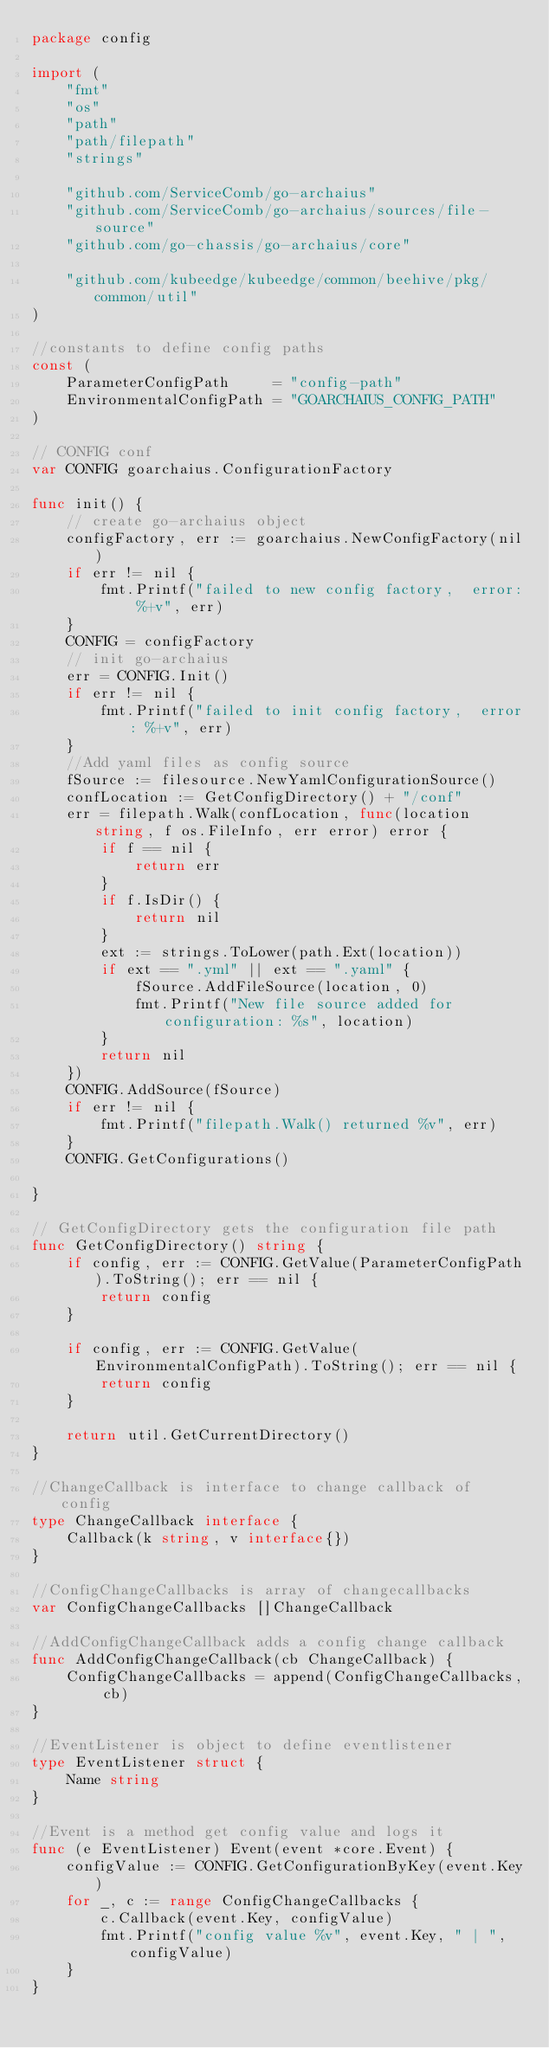Convert code to text. <code><loc_0><loc_0><loc_500><loc_500><_Go_>package config

import (
	"fmt"
	"os"
	"path"
	"path/filepath"
	"strings"

	"github.com/ServiceComb/go-archaius"
	"github.com/ServiceComb/go-archaius/sources/file-source"
	"github.com/go-chassis/go-archaius/core"

	"github.com/kubeedge/kubeedge/common/beehive/pkg/common/util"
)

//constants to define config paths
const (
	ParameterConfigPath     = "config-path"
	EnvironmentalConfigPath = "GOARCHAIUS_CONFIG_PATH"
)

// CONFIG conf
var CONFIG goarchaius.ConfigurationFactory

func init() {
	// create go-archaius object
	configFactory, err := goarchaius.NewConfigFactory(nil)
	if err != nil {
		fmt.Printf("failed to new config factory,  error: %+v", err)
	}
	CONFIG = configFactory
	// init go-archaius
	err = CONFIG.Init()
	if err != nil {
		fmt.Printf("failed to init config factory,  error: %+v", err)
	}
	//Add yaml files as config source
	fSource := filesource.NewYamlConfigurationSource()
	confLocation := GetConfigDirectory() + "/conf"
	err = filepath.Walk(confLocation, func(location string, f os.FileInfo, err error) error {
		if f == nil {
			return err
		}
		if f.IsDir() {
			return nil
		}
		ext := strings.ToLower(path.Ext(location))
		if ext == ".yml" || ext == ".yaml" {
			fSource.AddFileSource(location, 0)
			fmt.Printf("New file source added for configuration: %s", location)
		}
		return nil
	})
	CONFIG.AddSource(fSource)
	if err != nil {
		fmt.Printf("filepath.Walk() returned %v", err)
	}
	CONFIG.GetConfigurations()

}

// GetConfigDirectory gets the configuration file path
func GetConfigDirectory() string {
	if config, err := CONFIG.GetValue(ParameterConfigPath).ToString(); err == nil {
		return config
	}

	if config, err := CONFIG.GetValue(EnvironmentalConfigPath).ToString(); err == nil {
		return config
	}

	return util.GetCurrentDirectory()
}

//ChangeCallback is interface to change callback of config
type ChangeCallback interface {
	Callback(k string, v interface{})
}

//ConfigChangeCallbacks is array of changecallbacks
var ConfigChangeCallbacks []ChangeCallback

//AddConfigChangeCallback adds a config change callback
func AddConfigChangeCallback(cb ChangeCallback) {
	ConfigChangeCallbacks = append(ConfigChangeCallbacks, cb)
}

//EventListener is object to define eventlistener
type EventListener struct {
	Name string
}

//Event is a method get config value and logs it
func (e EventListener) Event(event *core.Event) {
	configValue := CONFIG.GetConfigurationByKey(event.Key)
	for _, c := range ConfigChangeCallbacks {
		c.Callback(event.Key, configValue)
		fmt.Printf("config value %v", event.Key, " | ", configValue)
	}
}
</code> 